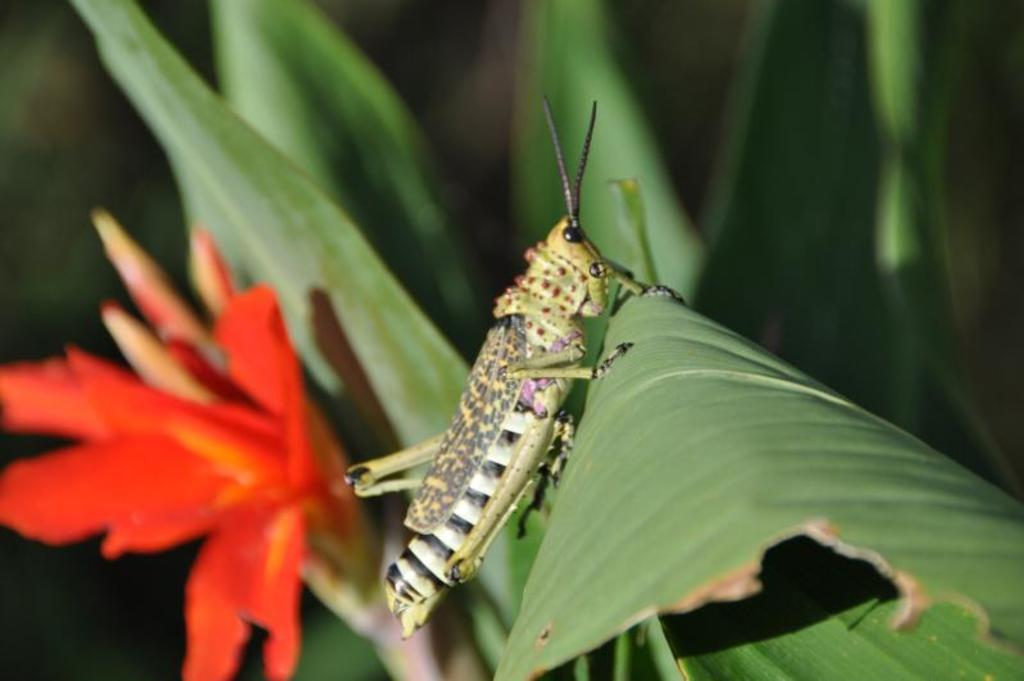What is on the leaf in the image? There is an insect on a leaf in the image. What can be seen in the background of the image? There are leaves and a flower in the background of the image. What type of industry can be seen in the background of the image? There is no industry present in the image; it features an insect on a leaf and leaves and a flower in the background. Can you tell me how many geese are visible in the image? There are no geese present in the image. 